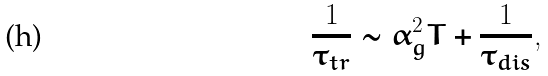<formula> <loc_0><loc_0><loc_500><loc_500>\frac { 1 } { \tau _ { t r } } \sim \alpha _ { g } ^ { 2 } T + \frac { 1 } { \tau _ { d i s } } ,</formula> 